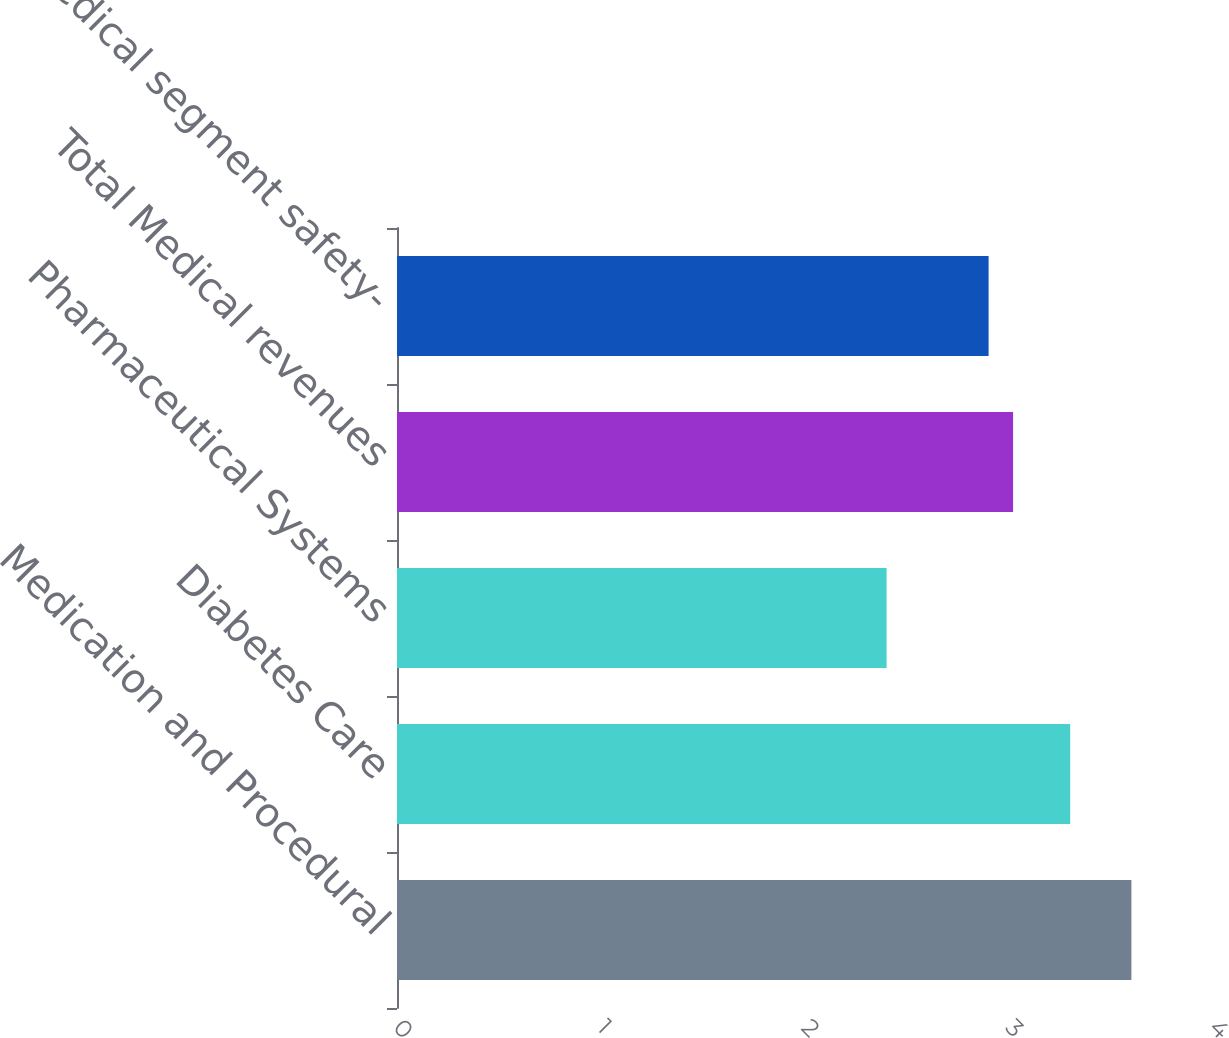<chart> <loc_0><loc_0><loc_500><loc_500><bar_chart><fcel>Medication and Procedural<fcel>Diabetes Care<fcel>Pharmaceutical Systems<fcel>Total Medical revenues<fcel>Medical segment safety-<nl><fcel>3.6<fcel>3.3<fcel>2.4<fcel>3.02<fcel>2.9<nl></chart> 